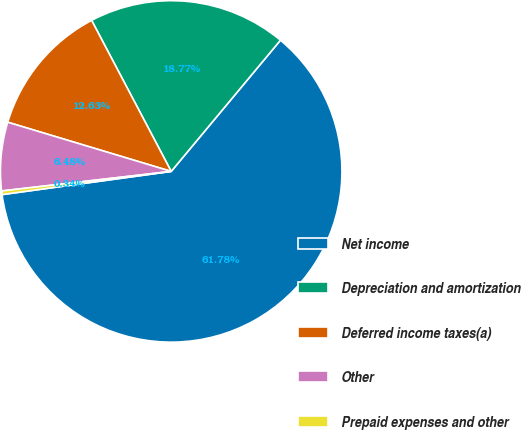Convert chart. <chart><loc_0><loc_0><loc_500><loc_500><pie_chart><fcel>Net income<fcel>Depreciation and amortization<fcel>Deferred income taxes(a)<fcel>Other<fcel>Prepaid expenses and other<nl><fcel>61.78%<fcel>18.77%<fcel>12.63%<fcel>6.48%<fcel>0.34%<nl></chart> 